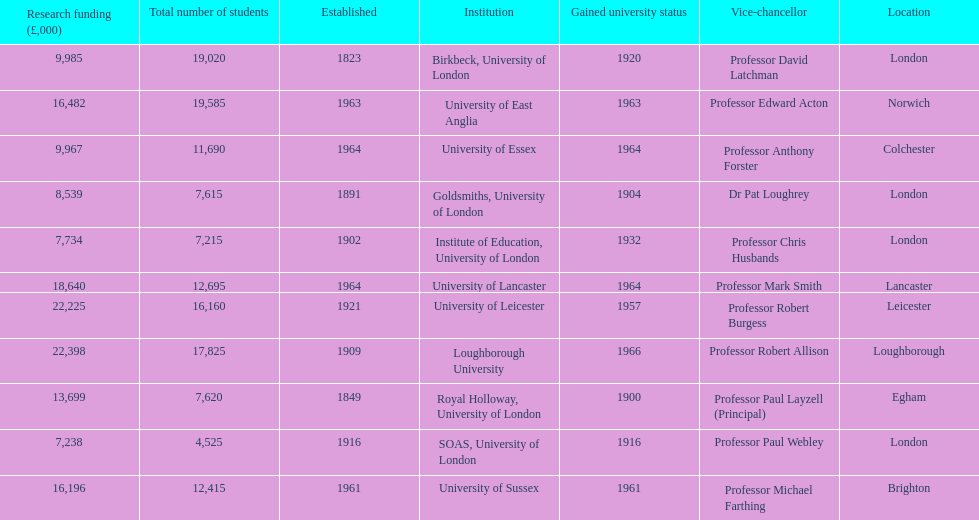Can you give me this table as a dict? {'header': ['Research funding (£,000)', 'Total number of students', 'Established', 'Institution', 'Gained university status', 'Vice-chancellor', 'Location'], 'rows': [['9,985', '19,020', '1823', 'Birkbeck, University of London', '1920', 'Professor David Latchman', 'London'], ['16,482', '19,585', '1963', 'University of East Anglia', '1963', 'Professor Edward Acton', 'Norwich'], ['9,967', '11,690', '1964', 'University of Essex', '1964', 'Professor Anthony Forster', 'Colchester'], ['8,539', '7,615', '1891', 'Goldsmiths, University of London', '1904', 'Dr Pat Loughrey', 'London'], ['7,734', '7,215', '1902', 'Institute of Education, University of London', '1932', 'Professor Chris Husbands', 'London'], ['18,640', '12,695', '1964', 'University of Lancaster', '1964', 'Professor Mark Smith', 'Lancaster'], ['22,225', '16,160', '1921', 'University of Leicester', '1957', 'Professor Robert Burgess', 'Leicester'], ['22,398', '17,825', '1909', 'Loughborough University', '1966', 'Professor Robert Allison', 'Loughborough'], ['13,699', '7,620', '1849', 'Royal Holloway, University of London', '1900', 'Professor Paul Layzell (Principal)', 'Egham'], ['7,238', '4,525', '1916', 'SOAS, University of London', '1916', 'Professor Paul Webley', 'London'], ['16,196', '12,415', '1961', 'University of Sussex', '1961', 'Professor Michael Farthing', 'Brighton']]} What is the most recent institution to gain university status? Loughborough University. 